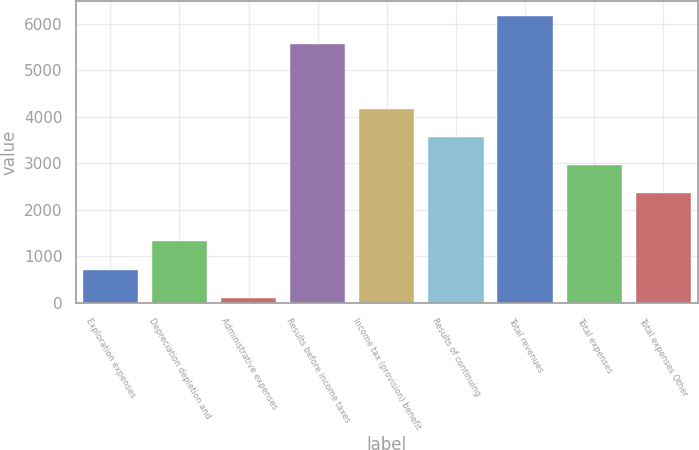Convert chart. <chart><loc_0><loc_0><loc_500><loc_500><bar_chart><fcel>Exploration expenses<fcel>Depreciation depletion and<fcel>Administrative expenses<fcel>Results before income taxes<fcel>Income tax (provision) benefit<fcel>Results of continuing<fcel>Total revenues<fcel>Total expenses<fcel>Total expenses Other<nl><fcel>704.4<fcel>1328<fcel>106<fcel>5573<fcel>4162.2<fcel>3563.8<fcel>6171.4<fcel>2965.4<fcel>2367<nl></chart> 